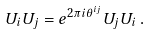<formula> <loc_0><loc_0><loc_500><loc_500>U _ { i } U _ { j } = e ^ { 2 \pi i \theta ^ { i j } } U _ { j } U _ { i } \, .</formula> 